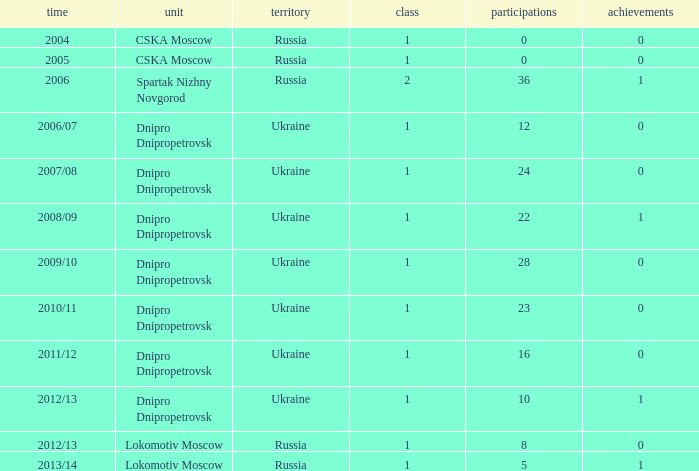What division was Ukraine in 2006/07? 1.0. Parse the full table. {'header': ['time', 'unit', 'territory', 'class', 'participations', 'achievements'], 'rows': [['2004', 'CSKA Moscow', 'Russia', '1', '0', '0'], ['2005', 'CSKA Moscow', 'Russia', '1', '0', '0'], ['2006', 'Spartak Nizhny Novgorod', 'Russia', '2', '36', '1'], ['2006/07', 'Dnipro Dnipropetrovsk', 'Ukraine', '1', '12', '0'], ['2007/08', 'Dnipro Dnipropetrovsk', 'Ukraine', '1', '24', '0'], ['2008/09', 'Dnipro Dnipropetrovsk', 'Ukraine', '1', '22', '1'], ['2009/10', 'Dnipro Dnipropetrovsk', 'Ukraine', '1', '28', '0'], ['2010/11', 'Dnipro Dnipropetrovsk', 'Ukraine', '1', '23', '0'], ['2011/12', 'Dnipro Dnipropetrovsk', 'Ukraine', '1', '16', '0'], ['2012/13', 'Dnipro Dnipropetrovsk', 'Ukraine', '1', '10', '1'], ['2012/13', 'Lokomotiv Moscow', 'Russia', '1', '8', '0'], ['2013/14', 'Lokomotiv Moscow', 'Russia', '1', '5', '1']]} 